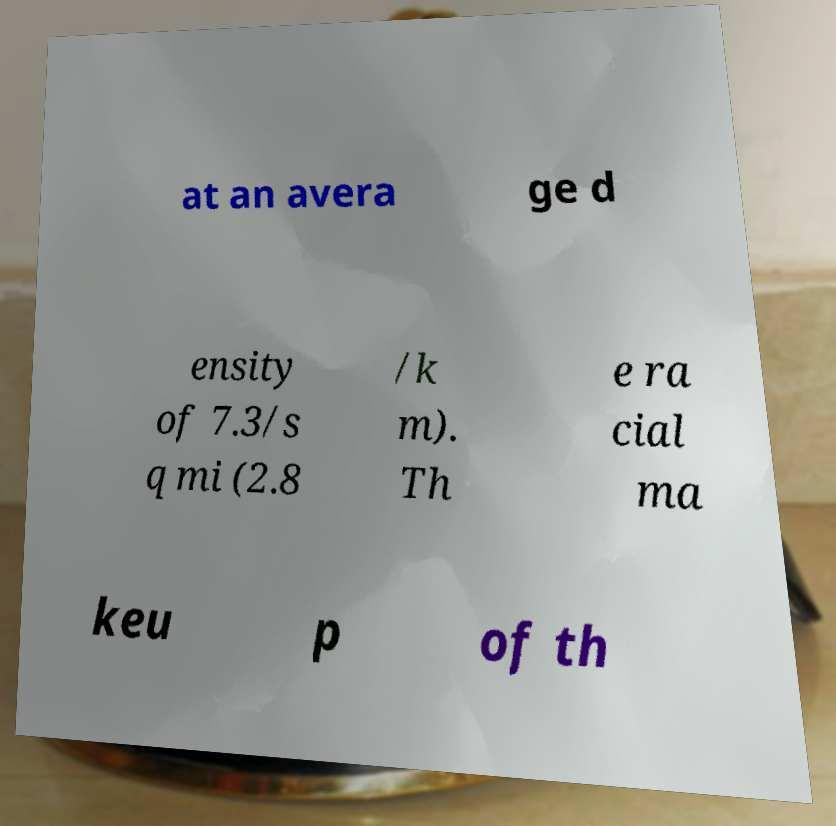Could you assist in decoding the text presented in this image and type it out clearly? at an avera ge d ensity of 7.3/s q mi (2.8 /k m). Th e ra cial ma keu p of th 